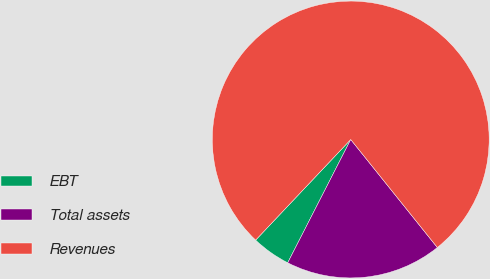<chart> <loc_0><loc_0><loc_500><loc_500><pie_chart><fcel>EBT<fcel>Total assets<fcel>Revenues<nl><fcel>4.53%<fcel>18.28%<fcel>77.19%<nl></chart> 